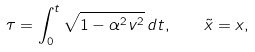<formula> <loc_0><loc_0><loc_500><loc_500>\tau = \int _ { 0 } ^ { t } \sqrt { 1 - \alpha ^ { 2 } v ^ { 2 } } \, d t , \quad \tilde { x } = x ,</formula> 